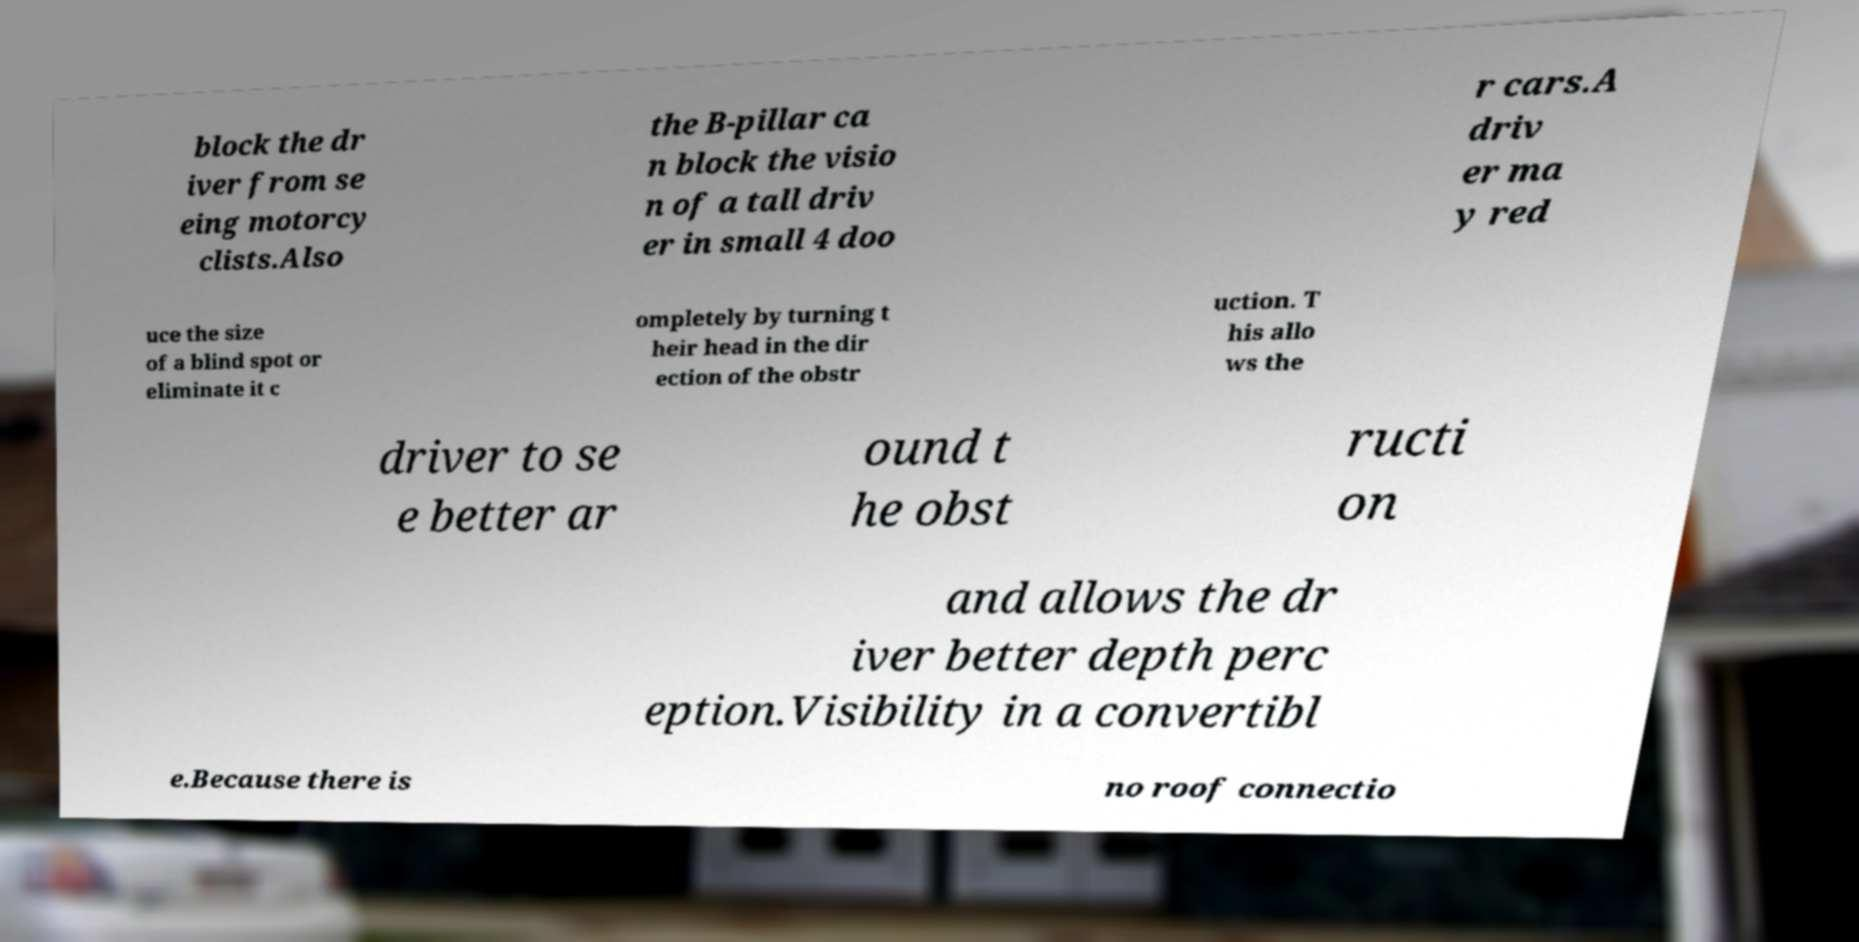I need the written content from this picture converted into text. Can you do that? block the dr iver from se eing motorcy clists.Also the B-pillar ca n block the visio n of a tall driv er in small 4 doo r cars.A driv er ma y red uce the size of a blind spot or eliminate it c ompletely by turning t heir head in the dir ection of the obstr uction. T his allo ws the driver to se e better ar ound t he obst ructi on and allows the dr iver better depth perc eption.Visibility in a convertibl e.Because there is no roof connectio 